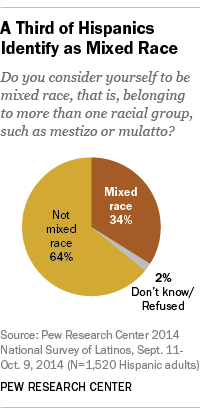Draw attention to some important aspects in this diagram. The difference in value between "Not mixed race" and "Mixed race" is 30 points. The largest pie in that section is not mixed race. 